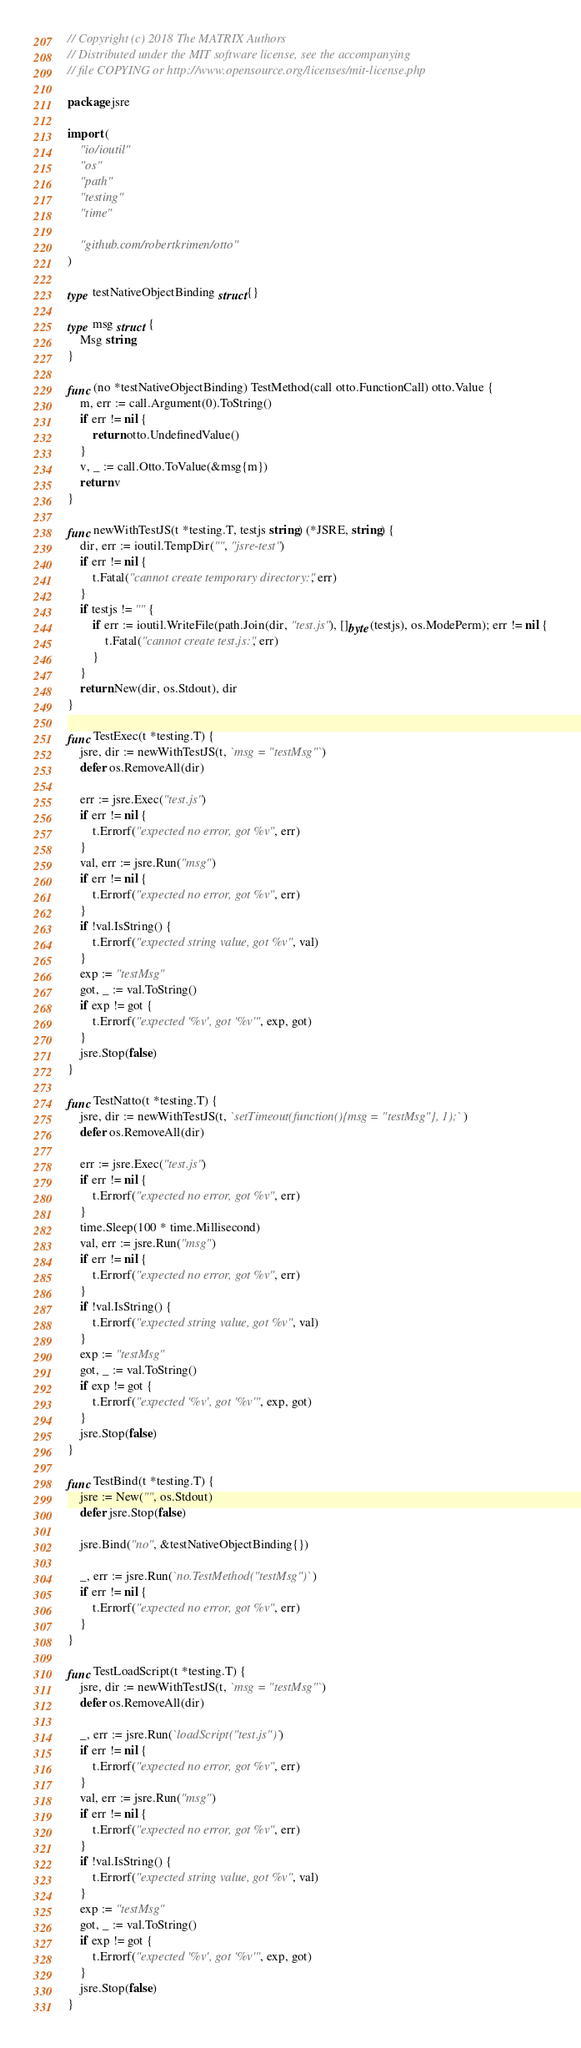<code> <loc_0><loc_0><loc_500><loc_500><_Go_>// Copyright (c) 2018 The MATRIX Authors
// Distributed under the MIT software license, see the accompanying
// file COPYING or http://www.opensource.org/licenses/mit-license.php

package jsre

import (
	"io/ioutil"
	"os"
	"path"
	"testing"
	"time"

	"github.com/robertkrimen/otto"
)

type testNativeObjectBinding struct{}

type msg struct {
	Msg string
}

func (no *testNativeObjectBinding) TestMethod(call otto.FunctionCall) otto.Value {
	m, err := call.Argument(0).ToString()
	if err != nil {
		return otto.UndefinedValue()
	}
	v, _ := call.Otto.ToValue(&msg{m})
	return v
}

func newWithTestJS(t *testing.T, testjs string) (*JSRE, string) {
	dir, err := ioutil.TempDir("", "jsre-test")
	if err != nil {
		t.Fatal("cannot create temporary directory:", err)
	}
	if testjs != "" {
		if err := ioutil.WriteFile(path.Join(dir, "test.js"), []byte(testjs), os.ModePerm); err != nil {
			t.Fatal("cannot create test.js:", err)
		}
	}
	return New(dir, os.Stdout), dir
}

func TestExec(t *testing.T) {
	jsre, dir := newWithTestJS(t, `msg = "testMsg"`)
	defer os.RemoveAll(dir)

	err := jsre.Exec("test.js")
	if err != nil {
		t.Errorf("expected no error, got %v", err)
	}
	val, err := jsre.Run("msg")
	if err != nil {
		t.Errorf("expected no error, got %v", err)
	}
	if !val.IsString() {
		t.Errorf("expected string value, got %v", val)
	}
	exp := "testMsg"
	got, _ := val.ToString()
	if exp != got {
		t.Errorf("expected '%v', got '%v'", exp, got)
	}
	jsre.Stop(false)
}

func TestNatto(t *testing.T) {
	jsre, dir := newWithTestJS(t, `setTimeout(function(){msg = "testMsg"}, 1);`)
	defer os.RemoveAll(dir)

	err := jsre.Exec("test.js")
	if err != nil {
		t.Errorf("expected no error, got %v", err)
	}
	time.Sleep(100 * time.Millisecond)
	val, err := jsre.Run("msg")
	if err != nil {
		t.Errorf("expected no error, got %v", err)
	}
	if !val.IsString() {
		t.Errorf("expected string value, got %v", val)
	}
	exp := "testMsg"
	got, _ := val.ToString()
	if exp != got {
		t.Errorf("expected '%v', got '%v'", exp, got)
	}
	jsre.Stop(false)
}

func TestBind(t *testing.T) {
	jsre := New("", os.Stdout)
	defer jsre.Stop(false)

	jsre.Bind("no", &testNativeObjectBinding{})

	_, err := jsre.Run(`no.TestMethod("testMsg")`)
	if err != nil {
		t.Errorf("expected no error, got %v", err)
	}
}

func TestLoadScript(t *testing.T) {
	jsre, dir := newWithTestJS(t, `msg = "testMsg"`)
	defer os.RemoveAll(dir)

	_, err := jsre.Run(`loadScript("test.js")`)
	if err != nil {
		t.Errorf("expected no error, got %v", err)
	}
	val, err := jsre.Run("msg")
	if err != nil {
		t.Errorf("expected no error, got %v", err)
	}
	if !val.IsString() {
		t.Errorf("expected string value, got %v", val)
	}
	exp := "testMsg"
	got, _ := val.ToString()
	if exp != got {
		t.Errorf("expected '%v', got '%v'", exp, got)
	}
	jsre.Stop(false)
}
</code> 